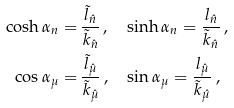<formula> <loc_0><loc_0><loc_500><loc_500>\cosh \alpha _ { n } = & \, \frac { { \tilde { l } } _ { \hat { n } } } { { \tilde { k } } _ { \hat { n } } } \, , \quad \sinh \alpha _ { n } = \frac { l _ { \hat { n } } } { { \tilde { k } } _ { \hat { n } } } \, , \\ \cos \alpha _ { \mu } = & \, \frac { { \tilde { l } } _ { \hat { \mu } } } { { \tilde { k } } _ { \hat { \mu } } } \, , \quad \sin \alpha _ { \mu } = \frac { l _ { \hat { \mu } } } { { \tilde { k } } _ { \hat { \mu } } } \, ,</formula> 